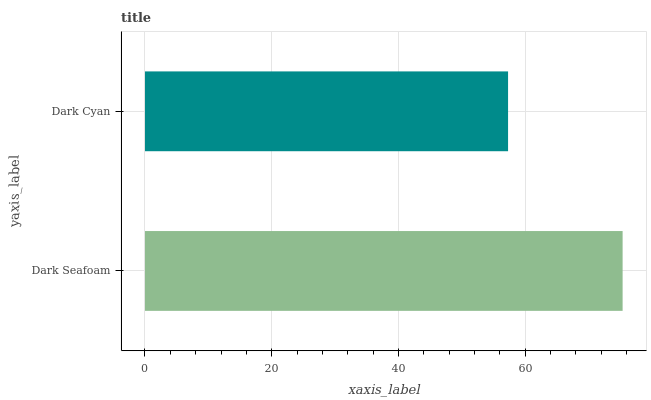Is Dark Cyan the minimum?
Answer yes or no. Yes. Is Dark Seafoam the maximum?
Answer yes or no. Yes. Is Dark Cyan the maximum?
Answer yes or no. No. Is Dark Seafoam greater than Dark Cyan?
Answer yes or no. Yes. Is Dark Cyan less than Dark Seafoam?
Answer yes or no. Yes. Is Dark Cyan greater than Dark Seafoam?
Answer yes or no. No. Is Dark Seafoam less than Dark Cyan?
Answer yes or no. No. Is Dark Seafoam the high median?
Answer yes or no. Yes. Is Dark Cyan the low median?
Answer yes or no. Yes. Is Dark Cyan the high median?
Answer yes or no. No. Is Dark Seafoam the low median?
Answer yes or no. No. 